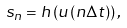<formula> <loc_0><loc_0><loc_500><loc_500>s _ { n } = h \left ( { { u } \left ( { n \Delta t } \right ) } \right ) ,</formula> 